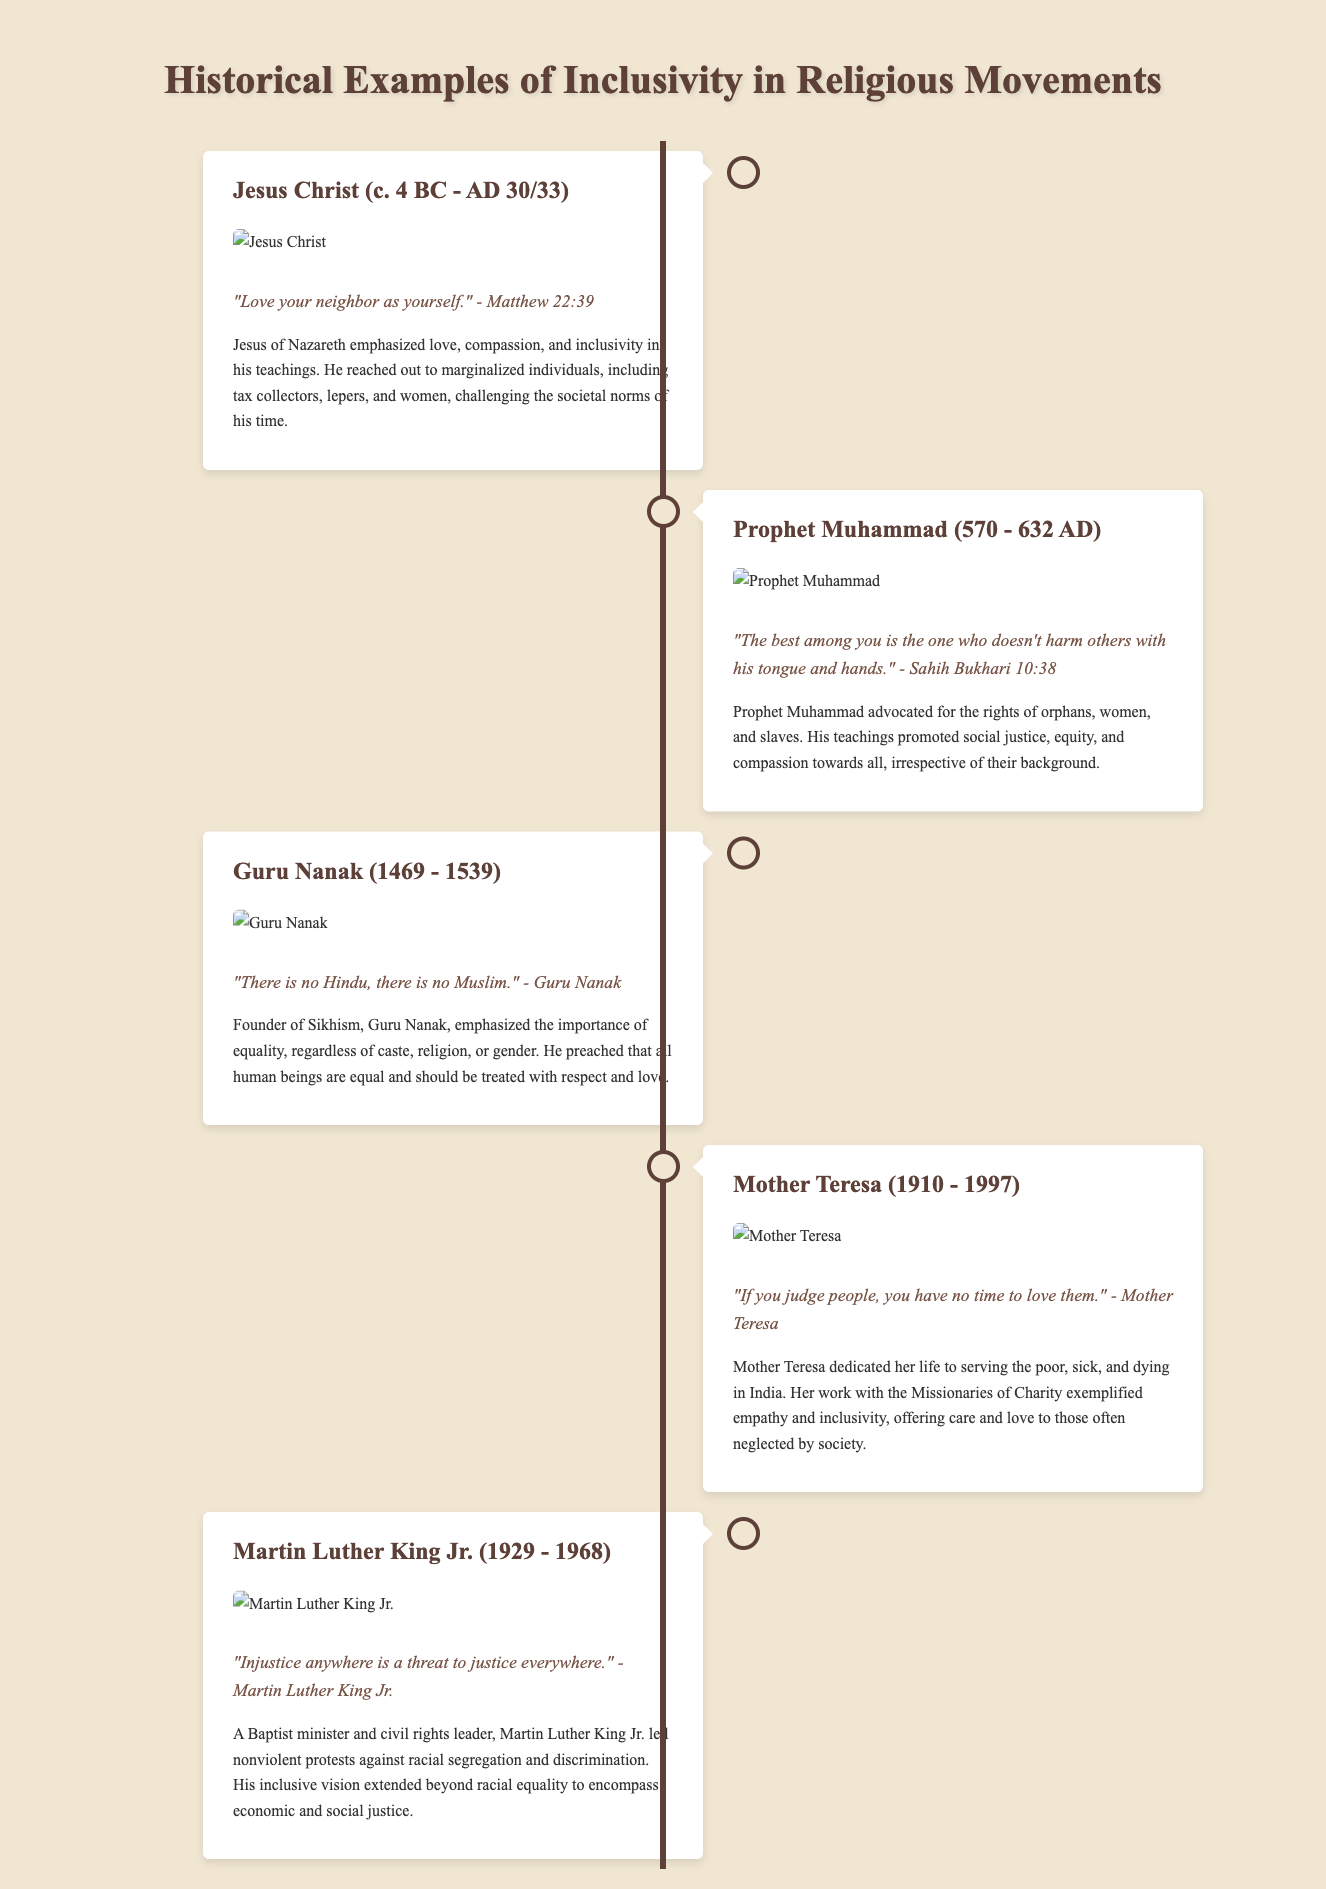What year was Jesus Christ born? According to the timeline, Jesus Christ was born around 4 BC.
Answer: 4 BC Who emphasized "Love your neighbor as yourself"? This quote, "Love your neighbor as yourself," is attributed to Jesus Christ in Matthew 22:39.
Answer: Jesus Christ What did Guru Nanak say about Hinduism and Islam? Guru Nanak stated, "There is no Hindu, there is no Muslim."
Answer: There is no Hindu, there is no Muslim When did Mother Teresa live? Mother Teresa was born in 1910 and passed away in 1997.
Answer: 1910 - 1997 What type of justice did Martin Luther King Jr. advocate for? Martin Luther King Jr. advocated for economic and social justice, as indicated in his quote relating to injustice.
Answer: Economic and social justice Which religious figure advocated rights for orphans, women, and slaves? This description pertains to Prophet Muhammad, who advocated for the rights of various marginalized groups.
Answer: Prophet Muhammad What movement is associated with Martin Luther King Jr.? Martin Luther King Jr. is associated with the civil rights movement as a leader advocating nonviolent protests.
Answer: Civil rights movement How did Mother Teresa show empathy in her work? Mother Teresa exemplified empathy by dedicating her life to serving the poor, sick, and dying.
Answer: Serving the poor, sick, and dying What does the timeline format illustrate? The timeline format illustrates historical examples of inclusivity in religious movements, showcasing different figures and their contributions.
Answer: Inclusivity in religious movements 